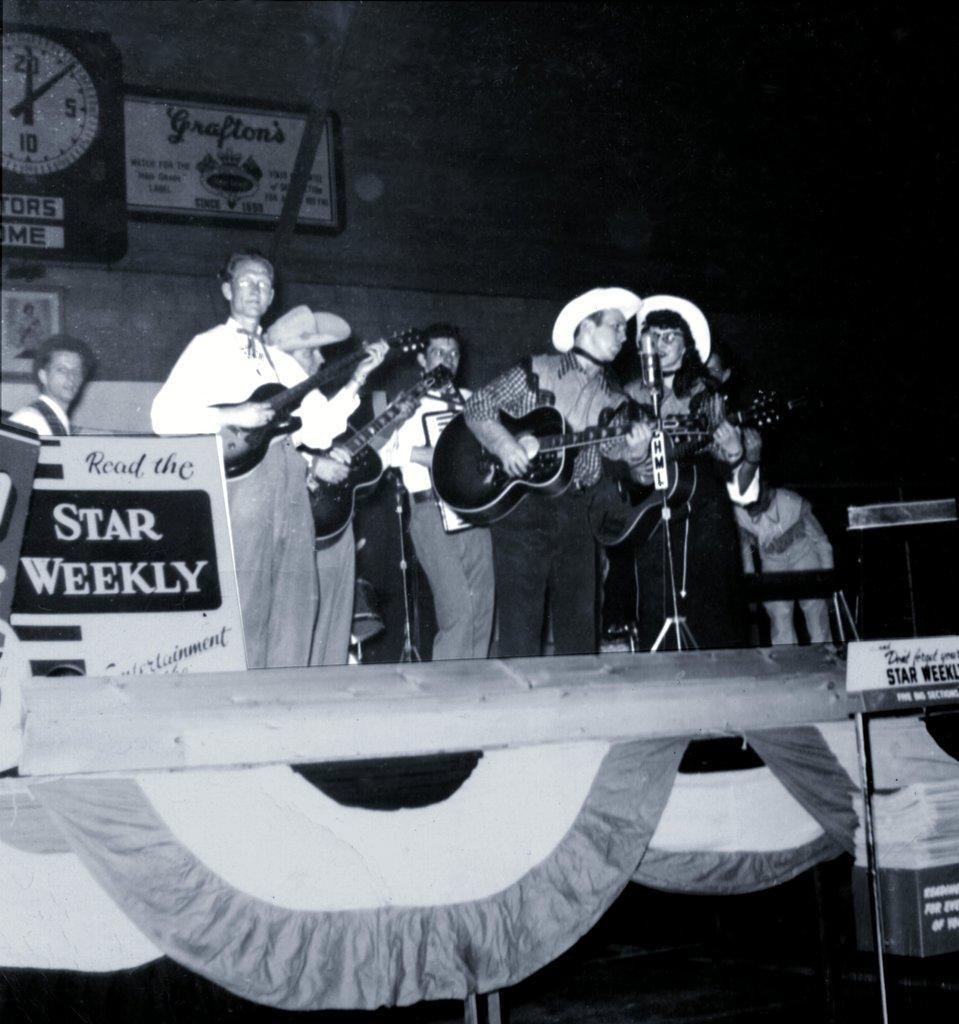Could you give a brief overview of what you see in this image? In the picture we can see an group of people holding the guitars and singing in the microphones. In the background we can see the wall clock, a person holding a hoarding. They are standing on the stage. 